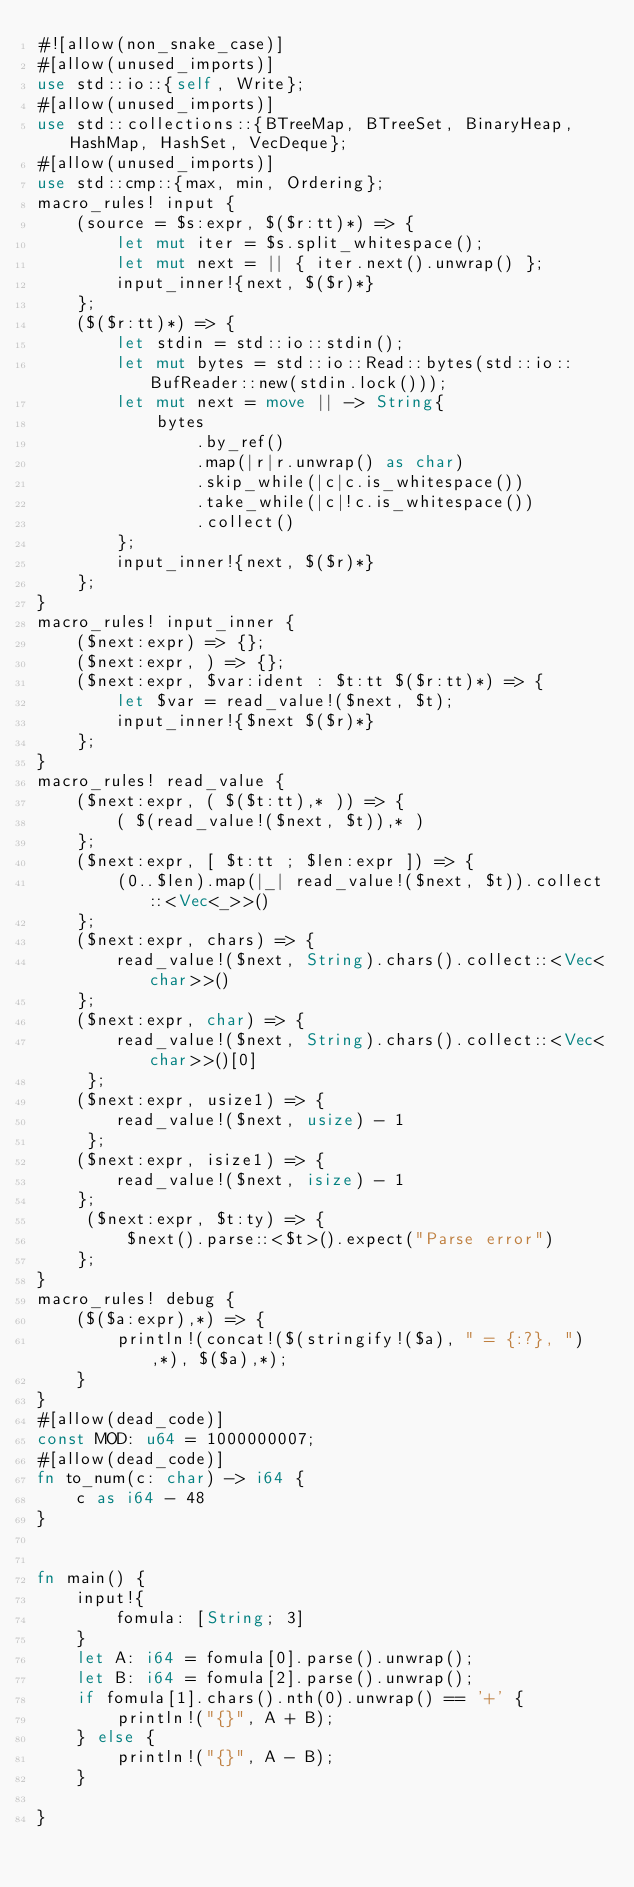<code> <loc_0><loc_0><loc_500><loc_500><_Rust_>#![allow(non_snake_case)]
#[allow(unused_imports)]
use std::io::{self, Write};
#[allow(unused_imports)]
use std::collections::{BTreeMap, BTreeSet, BinaryHeap, HashMap, HashSet, VecDeque};
#[allow(unused_imports)]
use std::cmp::{max, min, Ordering};
macro_rules! input {
    (source = $s:expr, $($r:tt)*) => {
        let mut iter = $s.split_whitespace();
        let mut next = || { iter.next().unwrap() };
        input_inner!{next, $($r)*}
    };
    ($($r:tt)*) => {
        let stdin = std::io::stdin();
        let mut bytes = std::io::Read::bytes(std::io::BufReader::new(stdin.lock()));
        let mut next = move || -> String{
            bytes
                .by_ref()
                .map(|r|r.unwrap() as char)
                .skip_while(|c|c.is_whitespace())
                .take_while(|c|!c.is_whitespace())
                .collect()
        };
        input_inner!{next, $($r)*}
    };
}
macro_rules! input_inner {
    ($next:expr) => {};
    ($next:expr, ) => {};
    ($next:expr, $var:ident : $t:tt $($r:tt)*) => {
        let $var = read_value!($next, $t);
        input_inner!{$next $($r)*}
    };
}
macro_rules! read_value {
    ($next:expr, ( $($t:tt),* )) => {
        ( $(read_value!($next, $t)),* )
    };
    ($next:expr, [ $t:tt ; $len:expr ]) => {
        (0..$len).map(|_| read_value!($next, $t)).collect::<Vec<_>>()
    };
    ($next:expr, chars) => {
        read_value!($next, String).chars().collect::<Vec<char>>()
    };
    ($next:expr, char) => {
        read_value!($next, String).chars().collect::<Vec<char>>()[0]
     };
    ($next:expr, usize1) => {
        read_value!($next, usize) - 1
     };
    ($next:expr, isize1) => {
        read_value!($next, isize) - 1
    };
     ($next:expr, $t:ty) => {
         $next().parse::<$t>().expect("Parse error")
    };
}
macro_rules! debug {
    ($($a:expr),*) => {
        println!(concat!($(stringify!($a), " = {:?}, "),*), $($a),*);
    }
}
#[allow(dead_code)]
const MOD: u64 = 1000000007;
#[allow(dead_code)]
fn to_num(c: char) -> i64 {
    c as i64 - 48
}


fn main() {
    input!{
        fomula: [String; 3]
    }
    let A: i64 = fomula[0].parse().unwrap();
    let B: i64 = fomula[2].parse().unwrap();
    if fomula[1].chars().nth(0).unwrap() == '+' {
        println!("{}", A + B);
    } else {
        println!("{}", A - B);
    }

}</code> 